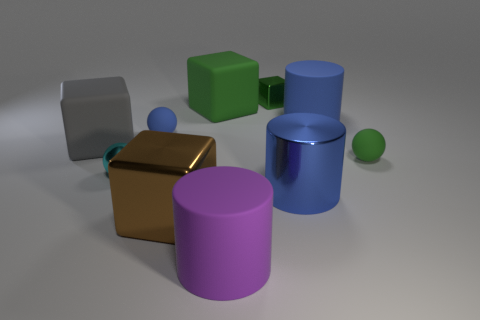Subtract all blue balls. How many green blocks are left? 2 Subtract all matte cylinders. How many cylinders are left? 1 Subtract 1 cylinders. How many cylinders are left? 2 Subtract all gray cubes. How many cubes are left? 3 Subtract all red cubes. Subtract all brown balls. How many cubes are left? 4 Subtract all cylinders. How many objects are left? 7 Subtract all large gray blocks. Subtract all big brown things. How many objects are left? 8 Add 1 tiny matte balls. How many tiny matte balls are left? 3 Add 6 big shiny cylinders. How many big shiny cylinders exist? 7 Subtract 0 yellow cylinders. How many objects are left? 10 